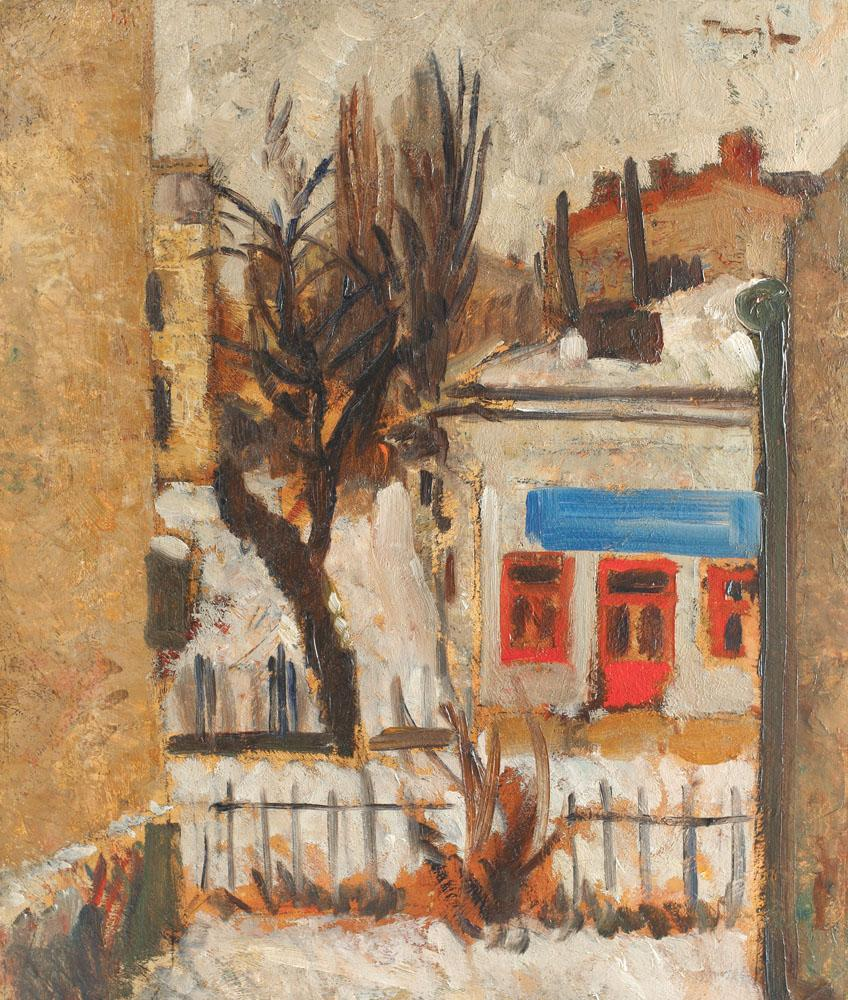Can you describe the mood conveyed by this painting? The composition exudes a sense of tranquility and nostalgia. The lack of foliage on the tree, along with the subdued light and earthy tones, might evoke the quietude of the colder months. The presence of the lamppost suggests the lingering presence of night or the early onset of morning. The solitude is palpable, yet not lonely; it's as if the scene is holding its breath, waiting for the day to begin. The distinct layering of paint and the rough textures contribute to a sense of intimacy, almost as if the viewer could step into the scene and hear the muffled sounds of the environment. 